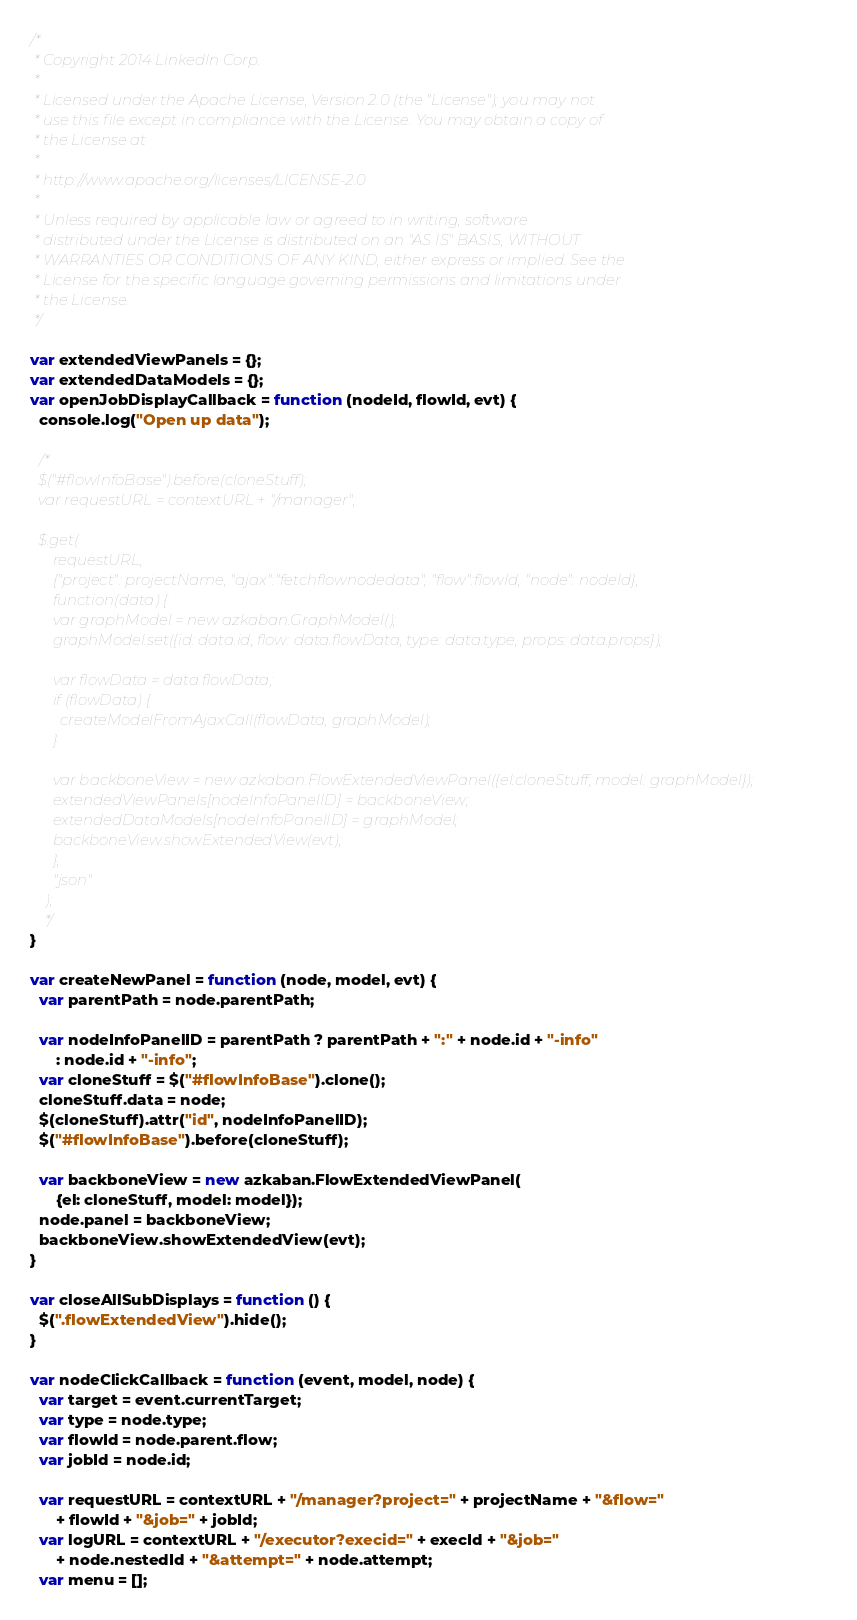Convert code to text. <code><loc_0><loc_0><loc_500><loc_500><_JavaScript_>/*
 * Copyright 2014 LinkedIn Corp.
 *
 * Licensed under the Apache License, Version 2.0 (the "License"); you may not
 * use this file except in compliance with the License. You may obtain a copy of
 * the License at
 *
 * http://www.apache.org/licenses/LICENSE-2.0
 *
 * Unless required by applicable law or agreed to in writing, software
 * distributed under the License is distributed on an "AS IS" BASIS, WITHOUT
 * WARRANTIES OR CONDITIONS OF ANY KIND, either express or implied. See the
 * License for the specific language governing permissions and limitations under
 * the License.
 */

var extendedViewPanels = {};
var extendedDataModels = {};
var openJobDisplayCallback = function (nodeId, flowId, evt) {
  console.log("Open up data");

  /*
  $("#flowInfoBase").before(cloneStuff);
  var requestURL = contextURL + "/manager";

  $.get(
      requestURL,
      {"project": projectName, "ajax":"fetchflownodedata", "flow":flowId, "node": nodeId},
      function(data) {
      var graphModel = new azkaban.GraphModel();
      graphModel.set({id: data.id, flow: data.flowData, type: data.type, props: data.props});

      var flowData = data.flowData;
      if (flowData) {
        createModelFromAjaxCall(flowData, graphModel);
      }

      var backboneView = new azkaban.FlowExtendedViewPanel({el:cloneStuff, model: graphModel});
      extendedViewPanels[nodeInfoPanelID] = backboneView;
      extendedDataModels[nodeInfoPanelID] = graphModel;
      backboneView.showExtendedView(evt);
      },
      "json"
    );
    */
}

var createNewPanel = function (node, model, evt) {
  var parentPath = node.parentPath;

  var nodeInfoPanelID = parentPath ? parentPath + ":" + node.id + "-info"
      : node.id + "-info";
  var cloneStuff = $("#flowInfoBase").clone();
  cloneStuff.data = node;
  $(cloneStuff).attr("id", nodeInfoPanelID);
  $("#flowInfoBase").before(cloneStuff);

  var backboneView = new azkaban.FlowExtendedViewPanel(
      {el: cloneStuff, model: model});
  node.panel = backboneView;
  backboneView.showExtendedView(evt);
}

var closeAllSubDisplays = function () {
  $(".flowExtendedView").hide();
}

var nodeClickCallback = function (event, model, node) {
  var target = event.currentTarget;
  var type = node.type;
  var flowId = node.parent.flow;
  var jobId = node.id;

  var requestURL = contextURL + "/manager?project=" + projectName + "&flow="
      + flowId + "&job=" + jobId;
  var logURL = contextURL + "/executor?execid=" + execId + "&job="
      + node.nestedId + "&attempt=" + node.attempt;
  var menu = [];
</code> 